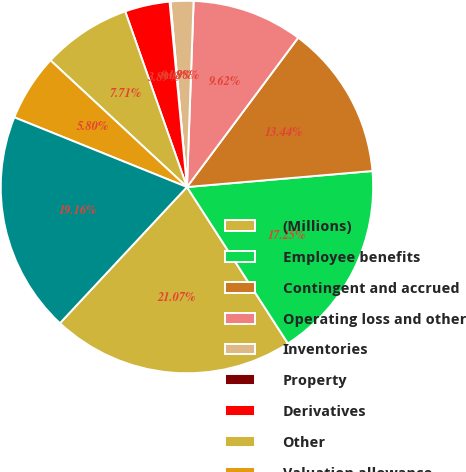Convert chart. <chart><loc_0><loc_0><loc_500><loc_500><pie_chart><fcel>(Millions)<fcel>Employee benefits<fcel>Contingent and accrued<fcel>Operating loss and other<fcel>Inventories<fcel>Property<fcel>Derivatives<fcel>Other<fcel>Valuation allowance<fcel>Total<nl><fcel>21.07%<fcel>17.25%<fcel>13.44%<fcel>9.62%<fcel>1.98%<fcel>0.08%<fcel>3.89%<fcel>7.71%<fcel>5.8%<fcel>19.16%<nl></chart> 